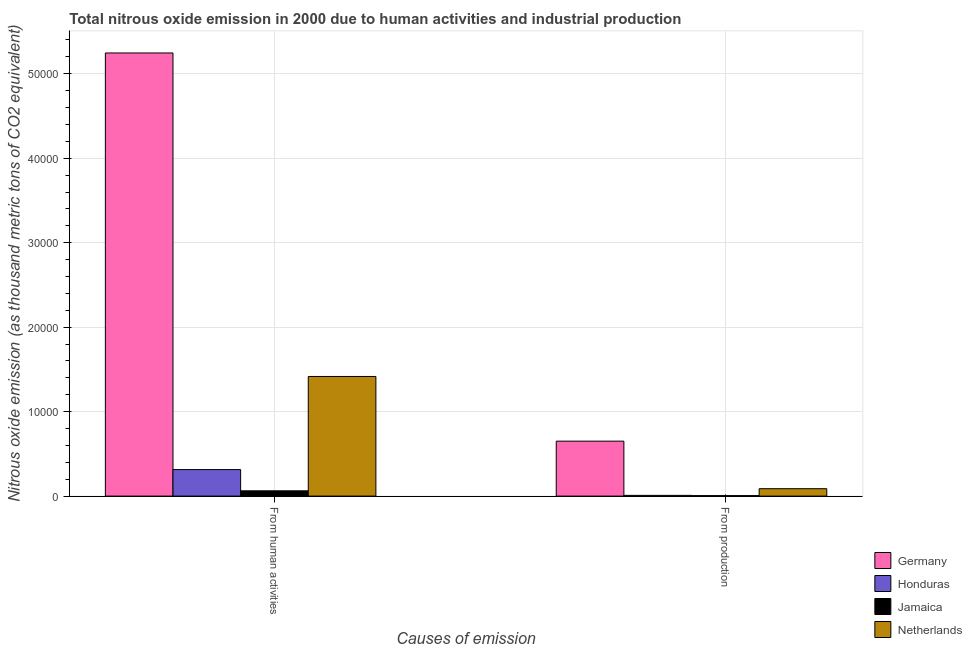Are the number of bars per tick equal to the number of legend labels?
Offer a very short reply. Yes. Are the number of bars on each tick of the X-axis equal?
Provide a succinct answer. Yes. How many bars are there on the 2nd tick from the right?
Your answer should be compact. 4. What is the label of the 2nd group of bars from the left?
Offer a terse response. From production. What is the amount of emissions from human activities in Netherlands?
Keep it short and to the point. 1.42e+04. Across all countries, what is the maximum amount of emissions from human activities?
Provide a short and direct response. 5.25e+04. Across all countries, what is the minimum amount of emissions generated from industries?
Offer a very short reply. 55.5. In which country was the amount of emissions from human activities maximum?
Give a very brief answer. Germany. In which country was the amount of emissions generated from industries minimum?
Ensure brevity in your answer.  Jamaica. What is the total amount of emissions from human activities in the graph?
Make the answer very short. 7.04e+04. What is the difference between the amount of emissions generated from industries in Honduras and that in Netherlands?
Give a very brief answer. -790.5. What is the difference between the amount of emissions generated from industries in Honduras and the amount of emissions from human activities in Germany?
Your answer should be compact. -5.24e+04. What is the average amount of emissions from human activities per country?
Offer a very short reply. 1.76e+04. What is the difference between the amount of emissions generated from industries and amount of emissions from human activities in Honduras?
Your answer should be very brief. -3054.7. In how many countries, is the amount of emissions from human activities greater than 32000 thousand metric tons?
Provide a short and direct response. 1. What is the ratio of the amount of emissions from human activities in Jamaica to that in Netherlands?
Give a very brief answer. 0.04. Is the amount of emissions generated from industries in Germany less than that in Honduras?
Your response must be concise. No. In how many countries, is the amount of emissions from human activities greater than the average amount of emissions from human activities taken over all countries?
Your response must be concise. 1. What does the 2nd bar from the right in From production represents?
Keep it short and to the point. Jamaica. Are all the bars in the graph horizontal?
Offer a terse response. No. What is the difference between two consecutive major ticks on the Y-axis?
Offer a terse response. 10000. Does the graph contain grids?
Ensure brevity in your answer.  Yes. How are the legend labels stacked?
Offer a terse response. Vertical. What is the title of the graph?
Offer a terse response. Total nitrous oxide emission in 2000 due to human activities and industrial production. Does "Nepal" appear as one of the legend labels in the graph?
Give a very brief answer. No. What is the label or title of the X-axis?
Give a very brief answer. Causes of emission. What is the label or title of the Y-axis?
Make the answer very short. Nitrous oxide emission (as thousand metric tons of CO2 equivalent). What is the Nitrous oxide emission (as thousand metric tons of CO2 equivalent) of Germany in From human activities?
Your answer should be very brief. 5.25e+04. What is the Nitrous oxide emission (as thousand metric tons of CO2 equivalent) of Honduras in From human activities?
Offer a terse response. 3142.2. What is the Nitrous oxide emission (as thousand metric tons of CO2 equivalent) in Jamaica in From human activities?
Give a very brief answer. 626.2. What is the Nitrous oxide emission (as thousand metric tons of CO2 equivalent) of Netherlands in From human activities?
Ensure brevity in your answer.  1.42e+04. What is the Nitrous oxide emission (as thousand metric tons of CO2 equivalent) in Germany in From production?
Ensure brevity in your answer.  6507. What is the Nitrous oxide emission (as thousand metric tons of CO2 equivalent) of Honduras in From production?
Make the answer very short. 87.5. What is the Nitrous oxide emission (as thousand metric tons of CO2 equivalent) of Jamaica in From production?
Provide a short and direct response. 55.5. What is the Nitrous oxide emission (as thousand metric tons of CO2 equivalent) of Netherlands in From production?
Offer a terse response. 878. Across all Causes of emission, what is the maximum Nitrous oxide emission (as thousand metric tons of CO2 equivalent) in Germany?
Provide a succinct answer. 5.25e+04. Across all Causes of emission, what is the maximum Nitrous oxide emission (as thousand metric tons of CO2 equivalent) of Honduras?
Your answer should be very brief. 3142.2. Across all Causes of emission, what is the maximum Nitrous oxide emission (as thousand metric tons of CO2 equivalent) of Jamaica?
Your response must be concise. 626.2. Across all Causes of emission, what is the maximum Nitrous oxide emission (as thousand metric tons of CO2 equivalent) in Netherlands?
Ensure brevity in your answer.  1.42e+04. Across all Causes of emission, what is the minimum Nitrous oxide emission (as thousand metric tons of CO2 equivalent) of Germany?
Ensure brevity in your answer.  6507. Across all Causes of emission, what is the minimum Nitrous oxide emission (as thousand metric tons of CO2 equivalent) in Honduras?
Provide a succinct answer. 87.5. Across all Causes of emission, what is the minimum Nitrous oxide emission (as thousand metric tons of CO2 equivalent) in Jamaica?
Offer a very short reply. 55.5. Across all Causes of emission, what is the minimum Nitrous oxide emission (as thousand metric tons of CO2 equivalent) of Netherlands?
Give a very brief answer. 878. What is the total Nitrous oxide emission (as thousand metric tons of CO2 equivalent) in Germany in the graph?
Give a very brief answer. 5.90e+04. What is the total Nitrous oxide emission (as thousand metric tons of CO2 equivalent) in Honduras in the graph?
Provide a succinct answer. 3229.7. What is the total Nitrous oxide emission (as thousand metric tons of CO2 equivalent) in Jamaica in the graph?
Your answer should be very brief. 681.7. What is the total Nitrous oxide emission (as thousand metric tons of CO2 equivalent) in Netherlands in the graph?
Your answer should be compact. 1.50e+04. What is the difference between the Nitrous oxide emission (as thousand metric tons of CO2 equivalent) in Germany in From human activities and that in From production?
Your answer should be very brief. 4.60e+04. What is the difference between the Nitrous oxide emission (as thousand metric tons of CO2 equivalent) in Honduras in From human activities and that in From production?
Your answer should be compact. 3054.7. What is the difference between the Nitrous oxide emission (as thousand metric tons of CO2 equivalent) in Jamaica in From human activities and that in From production?
Provide a succinct answer. 570.7. What is the difference between the Nitrous oxide emission (as thousand metric tons of CO2 equivalent) in Netherlands in From human activities and that in From production?
Provide a succinct answer. 1.33e+04. What is the difference between the Nitrous oxide emission (as thousand metric tons of CO2 equivalent) in Germany in From human activities and the Nitrous oxide emission (as thousand metric tons of CO2 equivalent) in Honduras in From production?
Offer a very short reply. 5.24e+04. What is the difference between the Nitrous oxide emission (as thousand metric tons of CO2 equivalent) in Germany in From human activities and the Nitrous oxide emission (as thousand metric tons of CO2 equivalent) in Jamaica in From production?
Keep it short and to the point. 5.24e+04. What is the difference between the Nitrous oxide emission (as thousand metric tons of CO2 equivalent) of Germany in From human activities and the Nitrous oxide emission (as thousand metric tons of CO2 equivalent) of Netherlands in From production?
Give a very brief answer. 5.16e+04. What is the difference between the Nitrous oxide emission (as thousand metric tons of CO2 equivalent) in Honduras in From human activities and the Nitrous oxide emission (as thousand metric tons of CO2 equivalent) in Jamaica in From production?
Keep it short and to the point. 3086.7. What is the difference between the Nitrous oxide emission (as thousand metric tons of CO2 equivalent) in Honduras in From human activities and the Nitrous oxide emission (as thousand metric tons of CO2 equivalent) in Netherlands in From production?
Provide a succinct answer. 2264.2. What is the difference between the Nitrous oxide emission (as thousand metric tons of CO2 equivalent) in Jamaica in From human activities and the Nitrous oxide emission (as thousand metric tons of CO2 equivalent) in Netherlands in From production?
Provide a short and direct response. -251.8. What is the average Nitrous oxide emission (as thousand metric tons of CO2 equivalent) of Germany per Causes of emission?
Provide a succinct answer. 2.95e+04. What is the average Nitrous oxide emission (as thousand metric tons of CO2 equivalent) of Honduras per Causes of emission?
Keep it short and to the point. 1614.85. What is the average Nitrous oxide emission (as thousand metric tons of CO2 equivalent) in Jamaica per Causes of emission?
Ensure brevity in your answer.  340.85. What is the average Nitrous oxide emission (as thousand metric tons of CO2 equivalent) of Netherlands per Causes of emission?
Your response must be concise. 7520.05. What is the difference between the Nitrous oxide emission (as thousand metric tons of CO2 equivalent) of Germany and Nitrous oxide emission (as thousand metric tons of CO2 equivalent) of Honduras in From human activities?
Provide a short and direct response. 4.93e+04. What is the difference between the Nitrous oxide emission (as thousand metric tons of CO2 equivalent) of Germany and Nitrous oxide emission (as thousand metric tons of CO2 equivalent) of Jamaica in From human activities?
Make the answer very short. 5.18e+04. What is the difference between the Nitrous oxide emission (as thousand metric tons of CO2 equivalent) of Germany and Nitrous oxide emission (as thousand metric tons of CO2 equivalent) of Netherlands in From human activities?
Give a very brief answer. 3.83e+04. What is the difference between the Nitrous oxide emission (as thousand metric tons of CO2 equivalent) in Honduras and Nitrous oxide emission (as thousand metric tons of CO2 equivalent) in Jamaica in From human activities?
Give a very brief answer. 2516. What is the difference between the Nitrous oxide emission (as thousand metric tons of CO2 equivalent) in Honduras and Nitrous oxide emission (as thousand metric tons of CO2 equivalent) in Netherlands in From human activities?
Your answer should be compact. -1.10e+04. What is the difference between the Nitrous oxide emission (as thousand metric tons of CO2 equivalent) of Jamaica and Nitrous oxide emission (as thousand metric tons of CO2 equivalent) of Netherlands in From human activities?
Keep it short and to the point. -1.35e+04. What is the difference between the Nitrous oxide emission (as thousand metric tons of CO2 equivalent) of Germany and Nitrous oxide emission (as thousand metric tons of CO2 equivalent) of Honduras in From production?
Provide a short and direct response. 6419.5. What is the difference between the Nitrous oxide emission (as thousand metric tons of CO2 equivalent) of Germany and Nitrous oxide emission (as thousand metric tons of CO2 equivalent) of Jamaica in From production?
Your answer should be compact. 6451.5. What is the difference between the Nitrous oxide emission (as thousand metric tons of CO2 equivalent) in Germany and Nitrous oxide emission (as thousand metric tons of CO2 equivalent) in Netherlands in From production?
Ensure brevity in your answer.  5629. What is the difference between the Nitrous oxide emission (as thousand metric tons of CO2 equivalent) in Honduras and Nitrous oxide emission (as thousand metric tons of CO2 equivalent) in Jamaica in From production?
Offer a very short reply. 32. What is the difference between the Nitrous oxide emission (as thousand metric tons of CO2 equivalent) in Honduras and Nitrous oxide emission (as thousand metric tons of CO2 equivalent) in Netherlands in From production?
Make the answer very short. -790.5. What is the difference between the Nitrous oxide emission (as thousand metric tons of CO2 equivalent) in Jamaica and Nitrous oxide emission (as thousand metric tons of CO2 equivalent) in Netherlands in From production?
Provide a succinct answer. -822.5. What is the ratio of the Nitrous oxide emission (as thousand metric tons of CO2 equivalent) of Germany in From human activities to that in From production?
Ensure brevity in your answer.  8.06. What is the ratio of the Nitrous oxide emission (as thousand metric tons of CO2 equivalent) of Honduras in From human activities to that in From production?
Ensure brevity in your answer.  35.91. What is the ratio of the Nitrous oxide emission (as thousand metric tons of CO2 equivalent) of Jamaica in From human activities to that in From production?
Give a very brief answer. 11.28. What is the ratio of the Nitrous oxide emission (as thousand metric tons of CO2 equivalent) in Netherlands in From human activities to that in From production?
Make the answer very short. 16.13. What is the difference between the highest and the second highest Nitrous oxide emission (as thousand metric tons of CO2 equivalent) in Germany?
Give a very brief answer. 4.60e+04. What is the difference between the highest and the second highest Nitrous oxide emission (as thousand metric tons of CO2 equivalent) of Honduras?
Provide a succinct answer. 3054.7. What is the difference between the highest and the second highest Nitrous oxide emission (as thousand metric tons of CO2 equivalent) of Jamaica?
Make the answer very short. 570.7. What is the difference between the highest and the second highest Nitrous oxide emission (as thousand metric tons of CO2 equivalent) in Netherlands?
Provide a short and direct response. 1.33e+04. What is the difference between the highest and the lowest Nitrous oxide emission (as thousand metric tons of CO2 equivalent) in Germany?
Your answer should be very brief. 4.60e+04. What is the difference between the highest and the lowest Nitrous oxide emission (as thousand metric tons of CO2 equivalent) in Honduras?
Provide a short and direct response. 3054.7. What is the difference between the highest and the lowest Nitrous oxide emission (as thousand metric tons of CO2 equivalent) in Jamaica?
Offer a terse response. 570.7. What is the difference between the highest and the lowest Nitrous oxide emission (as thousand metric tons of CO2 equivalent) in Netherlands?
Your response must be concise. 1.33e+04. 